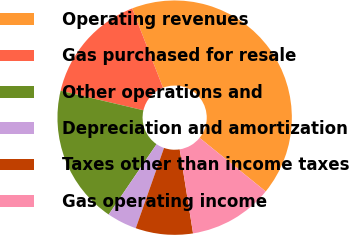Convert chart to OTSL. <chart><loc_0><loc_0><loc_500><loc_500><pie_chart><fcel>Operating revenues<fcel>Gas purchased for resale<fcel>Other operations and<fcel>Depreciation and amortization<fcel>Taxes other than income taxes<fcel>Gas operating income<nl><fcel>41.74%<fcel>15.41%<fcel>19.17%<fcel>4.13%<fcel>7.89%<fcel>11.65%<nl></chart> 